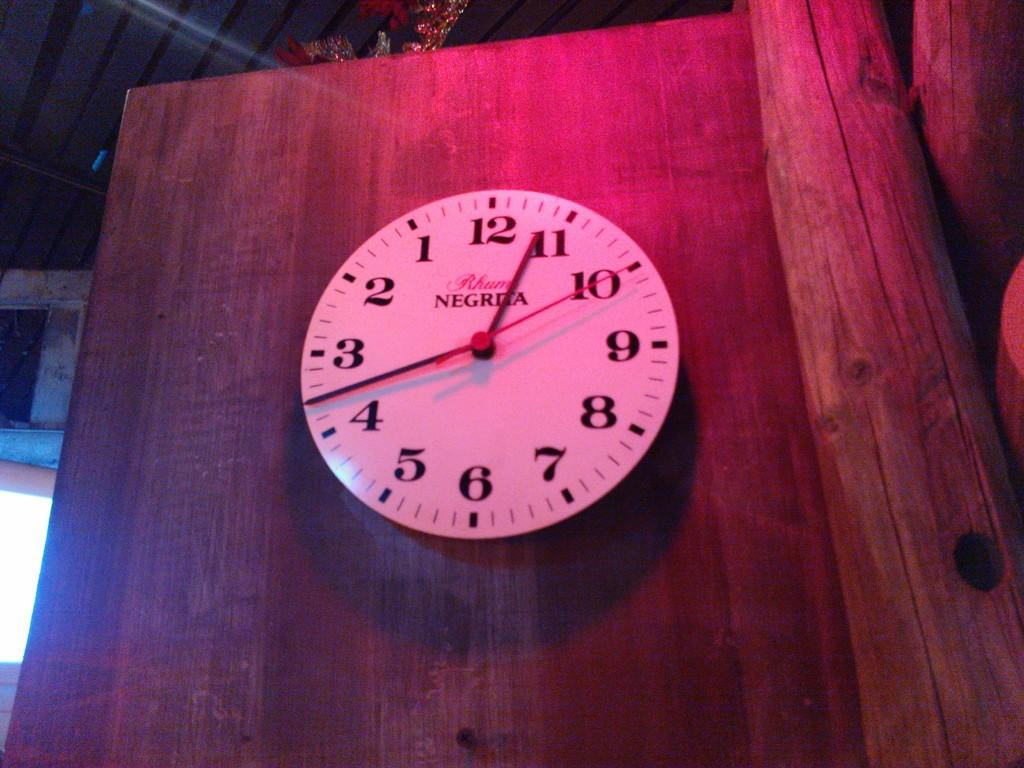<image>
Offer a succinct explanation of the picture presented. A clock on a wooden door was made by Negrita 